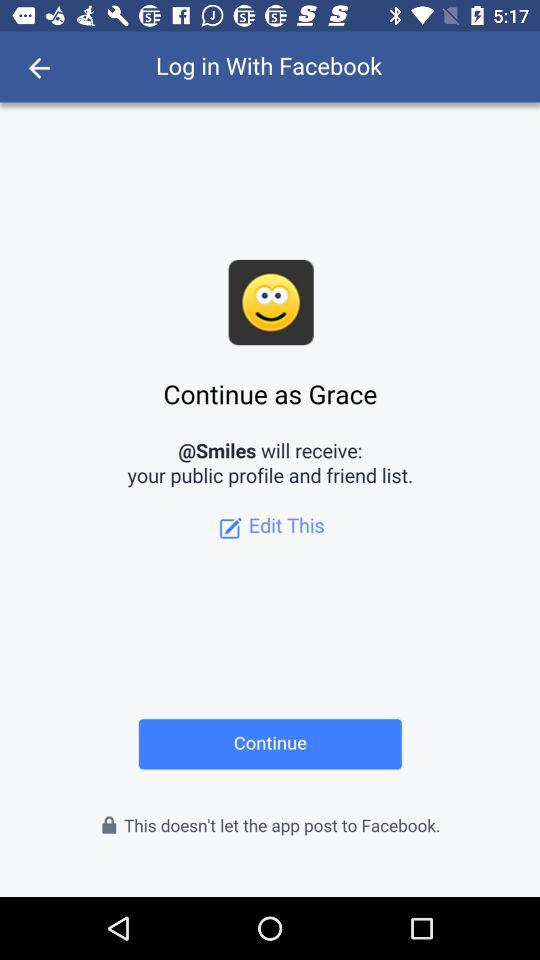Through what application can we log in? You can log in through "Facebook". 